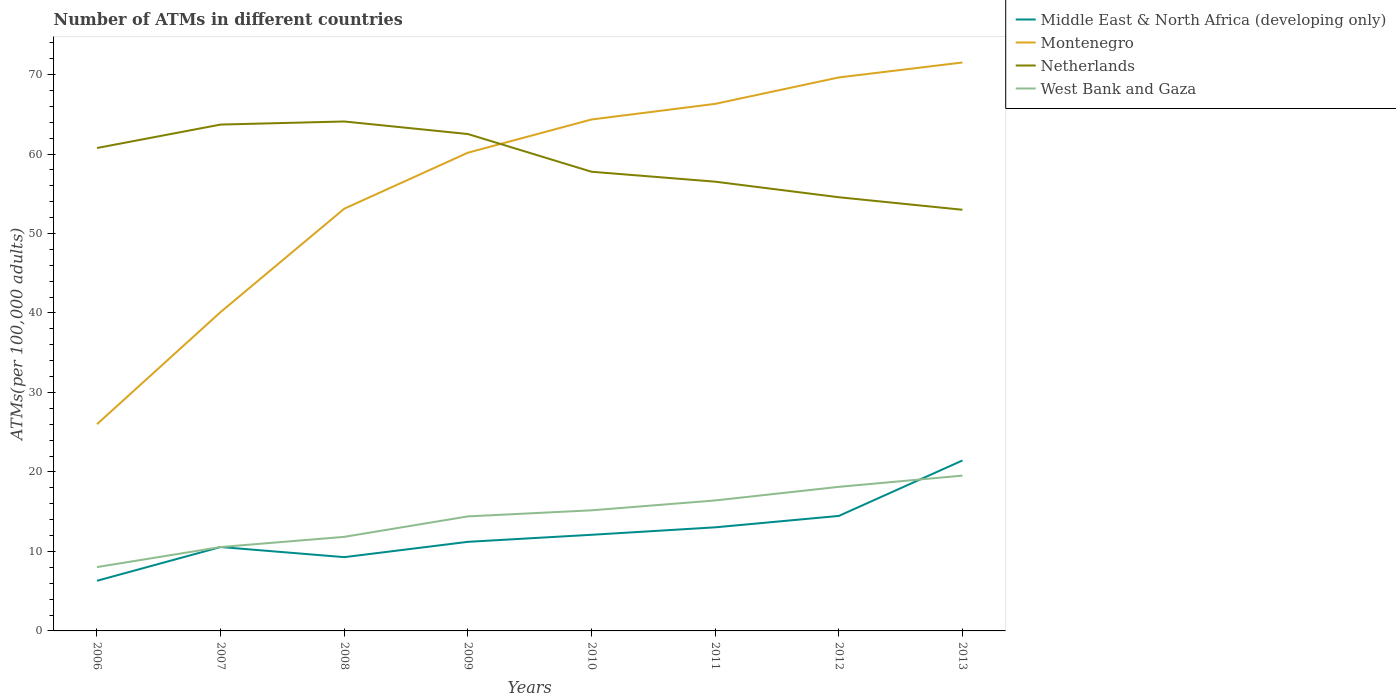How many different coloured lines are there?
Offer a terse response. 4. Does the line corresponding to Netherlands intersect with the line corresponding to Montenegro?
Your answer should be very brief. Yes. Is the number of lines equal to the number of legend labels?
Your answer should be compact. Yes. Across all years, what is the maximum number of ATMs in Middle East & North Africa (developing only)?
Provide a succinct answer. 6.31. In which year was the number of ATMs in West Bank and Gaza maximum?
Give a very brief answer. 2006. What is the total number of ATMs in Montenegro in the graph?
Ensure brevity in your answer.  -11.35. What is the difference between the highest and the second highest number of ATMs in Middle East & North Africa (developing only)?
Offer a very short reply. 15.13. How many lines are there?
Provide a short and direct response. 4. Are the values on the major ticks of Y-axis written in scientific E-notation?
Keep it short and to the point. No. Where does the legend appear in the graph?
Make the answer very short. Top right. How are the legend labels stacked?
Make the answer very short. Vertical. What is the title of the graph?
Ensure brevity in your answer.  Number of ATMs in different countries. What is the label or title of the X-axis?
Your answer should be compact. Years. What is the label or title of the Y-axis?
Your answer should be compact. ATMs(per 100,0 adults). What is the ATMs(per 100,000 adults) of Middle East & North Africa (developing only) in 2006?
Keep it short and to the point. 6.31. What is the ATMs(per 100,000 adults) of Montenegro in 2006?
Offer a very short reply. 26.01. What is the ATMs(per 100,000 adults) of Netherlands in 2006?
Give a very brief answer. 60.76. What is the ATMs(per 100,000 adults) in West Bank and Gaza in 2006?
Your answer should be compact. 8.03. What is the ATMs(per 100,000 adults) of Middle East & North Africa (developing only) in 2007?
Your answer should be compact. 10.56. What is the ATMs(per 100,000 adults) of Montenegro in 2007?
Provide a succinct answer. 40.12. What is the ATMs(per 100,000 adults) in Netherlands in 2007?
Make the answer very short. 63.71. What is the ATMs(per 100,000 adults) in West Bank and Gaza in 2007?
Keep it short and to the point. 10.56. What is the ATMs(per 100,000 adults) in Middle East & North Africa (developing only) in 2008?
Provide a short and direct response. 9.28. What is the ATMs(per 100,000 adults) of Montenegro in 2008?
Offer a very short reply. 53.12. What is the ATMs(per 100,000 adults) of Netherlands in 2008?
Keep it short and to the point. 64.1. What is the ATMs(per 100,000 adults) in West Bank and Gaza in 2008?
Keep it short and to the point. 11.84. What is the ATMs(per 100,000 adults) in Middle East & North Africa (developing only) in 2009?
Offer a very short reply. 11.21. What is the ATMs(per 100,000 adults) of Montenegro in 2009?
Provide a short and direct response. 60.17. What is the ATMs(per 100,000 adults) of Netherlands in 2009?
Your answer should be very brief. 62.52. What is the ATMs(per 100,000 adults) of West Bank and Gaza in 2009?
Provide a short and direct response. 14.41. What is the ATMs(per 100,000 adults) of Middle East & North Africa (developing only) in 2010?
Give a very brief answer. 12.09. What is the ATMs(per 100,000 adults) in Montenegro in 2010?
Give a very brief answer. 64.35. What is the ATMs(per 100,000 adults) in Netherlands in 2010?
Ensure brevity in your answer.  57.77. What is the ATMs(per 100,000 adults) of West Bank and Gaza in 2010?
Offer a terse response. 15.17. What is the ATMs(per 100,000 adults) of Middle East & North Africa (developing only) in 2011?
Provide a succinct answer. 13.03. What is the ATMs(per 100,000 adults) of Montenegro in 2011?
Your response must be concise. 66.31. What is the ATMs(per 100,000 adults) in Netherlands in 2011?
Provide a succinct answer. 56.52. What is the ATMs(per 100,000 adults) of West Bank and Gaza in 2011?
Ensure brevity in your answer.  16.42. What is the ATMs(per 100,000 adults) in Middle East & North Africa (developing only) in 2012?
Offer a terse response. 14.47. What is the ATMs(per 100,000 adults) in Montenegro in 2012?
Your answer should be compact. 69.64. What is the ATMs(per 100,000 adults) of Netherlands in 2012?
Make the answer very short. 54.56. What is the ATMs(per 100,000 adults) in West Bank and Gaza in 2012?
Provide a short and direct response. 18.13. What is the ATMs(per 100,000 adults) in Middle East & North Africa (developing only) in 2013?
Offer a very short reply. 21.44. What is the ATMs(per 100,000 adults) in Montenegro in 2013?
Ensure brevity in your answer.  71.52. What is the ATMs(per 100,000 adults) in Netherlands in 2013?
Keep it short and to the point. 52.99. What is the ATMs(per 100,000 adults) in West Bank and Gaza in 2013?
Your answer should be very brief. 19.54. Across all years, what is the maximum ATMs(per 100,000 adults) of Middle East & North Africa (developing only)?
Offer a terse response. 21.44. Across all years, what is the maximum ATMs(per 100,000 adults) of Montenegro?
Provide a succinct answer. 71.52. Across all years, what is the maximum ATMs(per 100,000 adults) in Netherlands?
Offer a terse response. 64.1. Across all years, what is the maximum ATMs(per 100,000 adults) in West Bank and Gaza?
Your answer should be compact. 19.54. Across all years, what is the minimum ATMs(per 100,000 adults) in Middle East & North Africa (developing only)?
Provide a succinct answer. 6.31. Across all years, what is the minimum ATMs(per 100,000 adults) of Montenegro?
Offer a very short reply. 26.01. Across all years, what is the minimum ATMs(per 100,000 adults) of Netherlands?
Offer a very short reply. 52.99. Across all years, what is the minimum ATMs(per 100,000 adults) of West Bank and Gaza?
Provide a short and direct response. 8.03. What is the total ATMs(per 100,000 adults) of Middle East & North Africa (developing only) in the graph?
Provide a succinct answer. 98.4. What is the total ATMs(per 100,000 adults) of Montenegro in the graph?
Give a very brief answer. 451.24. What is the total ATMs(per 100,000 adults) in Netherlands in the graph?
Your response must be concise. 472.93. What is the total ATMs(per 100,000 adults) of West Bank and Gaza in the graph?
Ensure brevity in your answer.  114.09. What is the difference between the ATMs(per 100,000 adults) in Middle East & North Africa (developing only) in 2006 and that in 2007?
Give a very brief answer. -4.25. What is the difference between the ATMs(per 100,000 adults) in Montenegro in 2006 and that in 2007?
Keep it short and to the point. -14.11. What is the difference between the ATMs(per 100,000 adults) of Netherlands in 2006 and that in 2007?
Offer a terse response. -2.95. What is the difference between the ATMs(per 100,000 adults) in West Bank and Gaza in 2006 and that in 2007?
Provide a succinct answer. -2.52. What is the difference between the ATMs(per 100,000 adults) of Middle East & North Africa (developing only) in 2006 and that in 2008?
Offer a terse response. -2.97. What is the difference between the ATMs(per 100,000 adults) in Montenegro in 2006 and that in 2008?
Ensure brevity in your answer.  -27.11. What is the difference between the ATMs(per 100,000 adults) of Netherlands in 2006 and that in 2008?
Give a very brief answer. -3.34. What is the difference between the ATMs(per 100,000 adults) in West Bank and Gaza in 2006 and that in 2008?
Offer a very short reply. -3.8. What is the difference between the ATMs(per 100,000 adults) of Middle East & North Africa (developing only) in 2006 and that in 2009?
Give a very brief answer. -4.9. What is the difference between the ATMs(per 100,000 adults) of Montenegro in 2006 and that in 2009?
Your answer should be very brief. -34.16. What is the difference between the ATMs(per 100,000 adults) in Netherlands in 2006 and that in 2009?
Your response must be concise. -1.76. What is the difference between the ATMs(per 100,000 adults) of West Bank and Gaza in 2006 and that in 2009?
Your response must be concise. -6.38. What is the difference between the ATMs(per 100,000 adults) of Middle East & North Africa (developing only) in 2006 and that in 2010?
Provide a succinct answer. -5.79. What is the difference between the ATMs(per 100,000 adults) of Montenegro in 2006 and that in 2010?
Provide a succinct answer. -38.34. What is the difference between the ATMs(per 100,000 adults) in Netherlands in 2006 and that in 2010?
Give a very brief answer. 2.99. What is the difference between the ATMs(per 100,000 adults) in West Bank and Gaza in 2006 and that in 2010?
Offer a very short reply. -7.14. What is the difference between the ATMs(per 100,000 adults) in Middle East & North Africa (developing only) in 2006 and that in 2011?
Your answer should be very brief. -6.72. What is the difference between the ATMs(per 100,000 adults) of Montenegro in 2006 and that in 2011?
Your answer should be very brief. -40.3. What is the difference between the ATMs(per 100,000 adults) of Netherlands in 2006 and that in 2011?
Provide a succinct answer. 4.24. What is the difference between the ATMs(per 100,000 adults) of West Bank and Gaza in 2006 and that in 2011?
Make the answer very short. -8.38. What is the difference between the ATMs(per 100,000 adults) of Middle East & North Africa (developing only) in 2006 and that in 2012?
Make the answer very short. -8.16. What is the difference between the ATMs(per 100,000 adults) of Montenegro in 2006 and that in 2012?
Offer a very short reply. -43.63. What is the difference between the ATMs(per 100,000 adults) of Netherlands in 2006 and that in 2012?
Your answer should be very brief. 6.19. What is the difference between the ATMs(per 100,000 adults) of West Bank and Gaza in 2006 and that in 2012?
Offer a terse response. -10.1. What is the difference between the ATMs(per 100,000 adults) of Middle East & North Africa (developing only) in 2006 and that in 2013?
Your response must be concise. -15.13. What is the difference between the ATMs(per 100,000 adults) of Montenegro in 2006 and that in 2013?
Keep it short and to the point. -45.51. What is the difference between the ATMs(per 100,000 adults) in Netherlands in 2006 and that in 2013?
Ensure brevity in your answer.  7.77. What is the difference between the ATMs(per 100,000 adults) in West Bank and Gaza in 2006 and that in 2013?
Provide a succinct answer. -11.51. What is the difference between the ATMs(per 100,000 adults) of Middle East & North Africa (developing only) in 2007 and that in 2008?
Give a very brief answer. 1.27. What is the difference between the ATMs(per 100,000 adults) of Montenegro in 2007 and that in 2008?
Give a very brief answer. -13. What is the difference between the ATMs(per 100,000 adults) in Netherlands in 2007 and that in 2008?
Ensure brevity in your answer.  -0.39. What is the difference between the ATMs(per 100,000 adults) of West Bank and Gaza in 2007 and that in 2008?
Provide a succinct answer. -1.28. What is the difference between the ATMs(per 100,000 adults) of Middle East & North Africa (developing only) in 2007 and that in 2009?
Make the answer very short. -0.65. What is the difference between the ATMs(per 100,000 adults) in Montenegro in 2007 and that in 2009?
Offer a very short reply. -20.05. What is the difference between the ATMs(per 100,000 adults) of Netherlands in 2007 and that in 2009?
Offer a very short reply. 1.19. What is the difference between the ATMs(per 100,000 adults) of West Bank and Gaza in 2007 and that in 2009?
Offer a very short reply. -3.85. What is the difference between the ATMs(per 100,000 adults) of Middle East & North Africa (developing only) in 2007 and that in 2010?
Offer a terse response. -1.54. What is the difference between the ATMs(per 100,000 adults) of Montenegro in 2007 and that in 2010?
Keep it short and to the point. -24.23. What is the difference between the ATMs(per 100,000 adults) of Netherlands in 2007 and that in 2010?
Your answer should be very brief. 5.94. What is the difference between the ATMs(per 100,000 adults) of West Bank and Gaza in 2007 and that in 2010?
Make the answer very short. -4.62. What is the difference between the ATMs(per 100,000 adults) in Middle East & North Africa (developing only) in 2007 and that in 2011?
Offer a very short reply. -2.48. What is the difference between the ATMs(per 100,000 adults) of Montenegro in 2007 and that in 2011?
Provide a short and direct response. -26.19. What is the difference between the ATMs(per 100,000 adults) of Netherlands in 2007 and that in 2011?
Offer a very short reply. 7.19. What is the difference between the ATMs(per 100,000 adults) in West Bank and Gaza in 2007 and that in 2011?
Provide a succinct answer. -5.86. What is the difference between the ATMs(per 100,000 adults) of Middle East & North Africa (developing only) in 2007 and that in 2012?
Offer a very short reply. -3.91. What is the difference between the ATMs(per 100,000 adults) of Montenegro in 2007 and that in 2012?
Your answer should be compact. -29.52. What is the difference between the ATMs(per 100,000 adults) in Netherlands in 2007 and that in 2012?
Your answer should be compact. 9.14. What is the difference between the ATMs(per 100,000 adults) of West Bank and Gaza in 2007 and that in 2012?
Make the answer very short. -7.57. What is the difference between the ATMs(per 100,000 adults) of Middle East & North Africa (developing only) in 2007 and that in 2013?
Give a very brief answer. -10.89. What is the difference between the ATMs(per 100,000 adults) of Montenegro in 2007 and that in 2013?
Ensure brevity in your answer.  -31.4. What is the difference between the ATMs(per 100,000 adults) of Netherlands in 2007 and that in 2013?
Ensure brevity in your answer.  10.72. What is the difference between the ATMs(per 100,000 adults) of West Bank and Gaza in 2007 and that in 2013?
Provide a short and direct response. -8.98. What is the difference between the ATMs(per 100,000 adults) of Middle East & North Africa (developing only) in 2008 and that in 2009?
Your answer should be very brief. -1.93. What is the difference between the ATMs(per 100,000 adults) in Montenegro in 2008 and that in 2009?
Your response must be concise. -7.05. What is the difference between the ATMs(per 100,000 adults) in Netherlands in 2008 and that in 2009?
Your answer should be very brief. 1.58. What is the difference between the ATMs(per 100,000 adults) in West Bank and Gaza in 2008 and that in 2009?
Give a very brief answer. -2.57. What is the difference between the ATMs(per 100,000 adults) in Middle East & North Africa (developing only) in 2008 and that in 2010?
Offer a very short reply. -2.81. What is the difference between the ATMs(per 100,000 adults) in Montenegro in 2008 and that in 2010?
Your answer should be compact. -11.22. What is the difference between the ATMs(per 100,000 adults) in Netherlands in 2008 and that in 2010?
Your answer should be compact. 6.32. What is the difference between the ATMs(per 100,000 adults) in West Bank and Gaza in 2008 and that in 2010?
Your answer should be compact. -3.34. What is the difference between the ATMs(per 100,000 adults) in Middle East & North Africa (developing only) in 2008 and that in 2011?
Offer a terse response. -3.75. What is the difference between the ATMs(per 100,000 adults) in Montenegro in 2008 and that in 2011?
Give a very brief answer. -13.19. What is the difference between the ATMs(per 100,000 adults) of Netherlands in 2008 and that in 2011?
Keep it short and to the point. 7.57. What is the difference between the ATMs(per 100,000 adults) of West Bank and Gaza in 2008 and that in 2011?
Give a very brief answer. -4.58. What is the difference between the ATMs(per 100,000 adults) in Middle East & North Africa (developing only) in 2008 and that in 2012?
Make the answer very short. -5.19. What is the difference between the ATMs(per 100,000 adults) in Montenegro in 2008 and that in 2012?
Provide a short and direct response. -16.51. What is the difference between the ATMs(per 100,000 adults) of Netherlands in 2008 and that in 2012?
Ensure brevity in your answer.  9.53. What is the difference between the ATMs(per 100,000 adults) in West Bank and Gaza in 2008 and that in 2012?
Ensure brevity in your answer.  -6.29. What is the difference between the ATMs(per 100,000 adults) of Middle East & North Africa (developing only) in 2008 and that in 2013?
Your answer should be compact. -12.16. What is the difference between the ATMs(per 100,000 adults) of Montenegro in 2008 and that in 2013?
Make the answer very short. -18.39. What is the difference between the ATMs(per 100,000 adults) of Netherlands in 2008 and that in 2013?
Your response must be concise. 11.11. What is the difference between the ATMs(per 100,000 adults) in West Bank and Gaza in 2008 and that in 2013?
Offer a very short reply. -7.7. What is the difference between the ATMs(per 100,000 adults) of Middle East & North Africa (developing only) in 2009 and that in 2010?
Provide a short and direct response. -0.89. What is the difference between the ATMs(per 100,000 adults) in Montenegro in 2009 and that in 2010?
Offer a very short reply. -4.18. What is the difference between the ATMs(per 100,000 adults) in Netherlands in 2009 and that in 2010?
Offer a terse response. 4.74. What is the difference between the ATMs(per 100,000 adults) in West Bank and Gaza in 2009 and that in 2010?
Keep it short and to the point. -0.76. What is the difference between the ATMs(per 100,000 adults) of Middle East & North Africa (developing only) in 2009 and that in 2011?
Make the answer very short. -1.82. What is the difference between the ATMs(per 100,000 adults) in Montenegro in 2009 and that in 2011?
Your answer should be very brief. -6.14. What is the difference between the ATMs(per 100,000 adults) in Netherlands in 2009 and that in 2011?
Offer a very short reply. 5.99. What is the difference between the ATMs(per 100,000 adults) of West Bank and Gaza in 2009 and that in 2011?
Provide a short and direct response. -2.01. What is the difference between the ATMs(per 100,000 adults) of Middle East & North Africa (developing only) in 2009 and that in 2012?
Your response must be concise. -3.26. What is the difference between the ATMs(per 100,000 adults) in Montenegro in 2009 and that in 2012?
Your answer should be very brief. -9.47. What is the difference between the ATMs(per 100,000 adults) of Netherlands in 2009 and that in 2012?
Your answer should be very brief. 7.95. What is the difference between the ATMs(per 100,000 adults) in West Bank and Gaza in 2009 and that in 2012?
Provide a short and direct response. -3.72. What is the difference between the ATMs(per 100,000 adults) in Middle East & North Africa (developing only) in 2009 and that in 2013?
Keep it short and to the point. -10.24. What is the difference between the ATMs(per 100,000 adults) of Montenegro in 2009 and that in 2013?
Offer a very short reply. -11.35. What is the difference between the ATMs(per 100,000 adults) of Netherlands in 2009 and that in 2013?
Your answer should be compact. 9.53. What is the difference between the ATMs(per 100,000 adults) in West Bank and Gaza in 2009 and that in 2013?
Your response must be concise. -5.13. What is the difference between the ATMs(per 100,000 adults) of Middle East & North Africa (developing only) in 2010 and that in 2011?
Your answer should be very brief. -0.94. What is the difference between the ATMs(per 100,000 adults) of Montenegro in 2010 and that in 2011?
Give a very brief answer. -1.96. What is the difference between the ATMs(per 100,000 adults) in Netherlands in 2010 and that in 2011?
Your answer should be very brief. 1.25. What is the difference between the ATMs(per 100,000 adults) of West Bank and Gaza in 2010 and that in 2011?
Keep it short and to the point. -1.24. What is the difference between the ATMs(per 100,000 adults) in Middle East & North Africa (developing only) in 2010 and that in 2012?
Provide a succinct answer. -2.37. What is the difference between the ATMs(per 100,000 adults) in Montenegro in 2010 and that in 2012?
Offer a terse response. -5.29. What is the difference between the ATMs(per 100,000 adults) in Netherlands in 2010 and that in 2012?
Provide a short and direct response. 3.21. What is the difference between the ATMs(per 100,000 adults) in West Bank and Gaza in 2010 and that in 2012?
Your answer should be very brief. -2.95. What is the difference between the ATMs(per 100,000 adults) in Middle East & North Africa (developing only) in 2010 and that in 2013?
Keep it short and to the point. -9.35. What is the difference between the ATMs(per 100,000 adults) of Montenegro in 2010 and that in 2013?
Make the answer very short. -7.17. What is the difference between the ATMs(per 100,000 adults) in Netherlands in 2010 and that in 2013?
Provide a succinct answer. 4.78. What is the difference between the ATMs(per 100,000 adults) of West Bank and Gaza in 2010 and that in 2013?
Give a very brief answer. -4.37. What is the difference between the ATMs(per 100,000 adults) of Middle East & North Africa (developing only) in 2011 and that in 2012?
Provide a short and direct response. -1.43. What is the difference between the ATMs(per 100,000 adults) of Montenegro in 2011 and that in 2012?
Make the answer very short. -3.32. What is the difference between the ATMs(per 100,000 adults) in Netherlands in 2011 and that in 2012?
Your response must be concise. 1.96. What is the difference between the ATMs(per 100,000 adults) of West Bank and Gaza in 2011 and that in 2012?
Make the answer very short. -1.71. What is the difference between the ATMs(per 100,000 adults) of Middle East & North Africa (developing only) in 2011 and that in 2013?
Give a very brief answer. -8.41. What is the difference between the ATMs(per 100,000 adults) of Montenegro in 2011 and that in 2013?
Provide a short and direct response. -5.21. What is the difference between the ATMs(per 100,000 adults) in Netherlands in 2011 and that in 2013?
Your answer should be compact. 3.53. What is the difference between the ATMs(per 100,000 adults) in West Bank and Gaza in 2011 and that in 2013?
Give a very brief answer. -3.12. What is the difference between the ATMs(per 100,000 adults) in Middle East & North Africa (developing only) in 2012 and that in 2013?
Your answer should be compact. -6.98. What is the difference between the ATMs(per 100,000 adults) of Montenegro in 2012 and that in 2013?
Provide a short and direct response. -1.88. What is the difference between the ATMs(per 100,000 adults) in Netherlands in 2012 and that in 2013?
Provide a short and direct response. 1.58. What is the difference between the ATMs(per 100,000 adults) of West Bank and Gaza in 2012 and that in 2013?
Offer a terse response. -1.41. What is the difference between the ATMs(per 100,000 adults) of Middle East & North Africa (developing only) in 2006 and the ATMs(per 100,000 adults) of Montenegro in 2007?
Ensure brevity in your answer.  -33.81. What is the difference between the ATMs(per 100,000 adults) in Middle East & North Africa (developing only) in 2006 and the ATMs(per 100,000 adults) in Netherlands in 2007?
Give a very brief answer. -57.4. What is the difference between the ATMs(per 100,000 adults) in Middle East & North Africa (developing only) in 2006 and the ATMs(per 100,000 adults) in West Bank and Gaza in 2007?
Offer a very short reply. -4.25. What is the difference between the ATMs(per 100,000 adults) in Montenegro in 2006 and the ATMs(per 100,000 adults) in Netherlands in 2007?
Offer a very short reply. -37.7. What is the difference between the ATMs(per 100,000 adults) of Montenegro in 2006 and the ATMs(per 100,000 adults) of West Bank and Gaza in 2007?
Provide a short and direct response. 15.46. What is the difference between the ATMs(per 100,000 adults) in Netherlands in 2006 and the ATMs(per 100,000 adults) in West Bank and Gaza in 2007?
Your answer should be very brief. 50.2. What is the difference between the ATMs(per 100,000 adults) of Middle East & North Africa (developing only) in 2006 and the ATMs(per 100,000 adults) of Montenegro in 2008?
Your response must be concise. -46.81. What is the difference between the ATMs(per 100,000 adults) of Middle East & North Africa (developing only) in 2006 and the ATMs(per 100,000 adults) of Netherlands in 2008?
Provide a short and direct response. -57.79. What is the difference between the ATMs(per 100,000 adults) of Middle East & North Africa (developing only) in 2006 and the ATMs(per 100,000 adults) of West Bank and Gaza in 2008?
Give a very brief answer. -5.53. What is the difference between the ATMs(per 100,000 adults) in Montenegro in 2006 and the ATMs(per 100,000 adults) in Netherlands in 2008?
Provide a succinct answer. -38.09. What is the difference between the ATMs(per 100,000 adults) of Montenegro in 2006 and the ATMs(per 100,000 adults) of West Bank and Gaza in 2008?
Ensure brevity in your answer.  14.18. What is the difference between the ATMs(per 100,000 adults) in Netherlands in 2006 and the ATMs(per 100,000 adults) in West Bank and Gaza in 2008?
Provide a short and direct response. 48.92. What is the difference between the ATMs(per 100,000 adults) of Middle East & North Africa (developing only) in 2006 and the ATMs(per 100,000 adults) of Montenegro in 2009?
Give a very brief answer. -53.86. What is the difference between the ATMs(per 100,000 adults) in Middle East & North Africa (developing only) in 2006 and the ATMs(per 100,000 adults) in Netherlands in 2009?
Offer a very short reply. -56.21. What is the difference between the ATMs(per 100,000 adults) in Montenegro in 2006 and the ATMs(per 100,000 adults) in Netherlands in 2009?
Provide a succinct answer. -36.51. What is the difference between the ATMs(per 100,000 adults) in Montenegro in 2006 and the ATMs(per 100,000 adults) in West Bank and Gaza in 2009?
Make the answer very short. 11.6. What is the difference between the ATMs(per 100,000 adults) in Netherlands in 2006 and the ATMs(per 100,000 adults) in West Bank and Gaza in 2009?
Offer a terse response. 46.35. What is the difference between the ATMs(per 100,000 adults) of Middle East & North Africa (developing only) in 2006 and the ATMs(per 100,000 adults) of Montenegro in 2010?
Give a very brief answer. -58.04. What is the difference between the ATMs(per 100,000 adults) in Middle East & North Africa (developing only) in 2006 and the ATMs(per 100,000 adults) in Netherlands in 2010?
Keep it short and to the point. -51.46. What is the difference between the ATMs(per 100,000 adults) in Middle East & North Africa (developing only) in 2006 and the ATMs(per 100,000 adults) in West Bank and Gaza in 2010?
Your response must be concise. -8.86. What is the difference between the ATMs(per 100,000 adults) of Montenegro in 2006 and the ATMs(per 100,000 adults) of Netherlands in 2010?
Offer a terse response. -31.76. What is the difference between the ATMs(per 100,000 adults) of Montenegro in 2006 and the ATMs(per 100,000 adults) of West Bank and Gaza in 2010?
Your answer should be compact. 10.84. What is the difference between the ATMs(per 100,000 adults) of Netherlands in 2006 and the ATMs(per 100,000 adults) of West Bank and Gaza in 2010?
Ensure brevity in your answer.  45.58. What is the difference between the ATMs(per 100,000 adults) of Middle East & North Africa (developing only) in 2006 and the ATMs(per 100,000 adults) of Montenegro in 2011?
Your answer should be compact. -60. What is the difference between the ATMs(per 100,000 adults) of Middle East & North Africa (developing only) in 2006 and the ATMs(per 100,000 adults) of Netherlands in 2011?
Make the answer very short. -50.21. What is the difference between the ATMs(per 100,000 adults) in Middle East & North Africa (developing only) in 2006 and the ATMs(per 100,000 adults) in West Bank and Gaza in 2011?
Your answer should be compact. -10.11. What is the difference between the ATMs(per 100,000 adults) of Montenegro in 2006 and the ATMs(per 100,000 adults) of Netherlands in 2011?
Make the answer very short. -30.51. What is the difference between the ATMs(per 100,000 adults) of Montenegro in 2006 and the ATMs(per 100,000 adults) of West Bank and Gaza in 2011?
Your answer should be compact. 9.6. What is the difference between the ATMs(per 100,000 adults) of Netherlands in 2006 and the ATMs(per 100,000 adults) of West Bank and Gaza in 2011?
Keep it short and to the point. 44.34. What is the difference between the ATMs(per 100,000 adults) in Middle East & North Africa (developing only) in 2006 and the ATMs(per 100,000 adults) in Montenegro in 2012?
Provide a succinct answer. -63.33. What is the difference between the ATMs(per 100,000 adults) of Middle East & North Africa (developing only) in 2006 and the ATMs(per 100,000 adults) of Netherlands in 2012?
Your response must be concise. -48.25. What is the difference between the ATMs(per 100,000 adults) of Middle East & North Africa (developing only) in 2006 and the ATMs(per 100,000 adults) of West Bank and Gaza in 2012?
Your answer should be very brief. -11.82. What is the difference between the ATMs(per 100,000 adults) in Montenegro in 2006 and the ATMs(per 100,000 adults) in Netherlands in 2012?
Your response must be concise. -28.55. What is the difference between the ATMs(per 100,000 adults) in Montenegro in 2006 and the ATMs(per 100,000 adults) in West Bank and Gaza in 2012?
Offer a terse response. 7.88. What is the difference between the ATMs(per 100,000 adults) of Netherlands in 2006 and the ATMs(per 100,000 adults) of West Bank and Gaza in 2012?
Give a very brief answer. 42.63. What is the difference between the ATMs(per 100,000 adults) in Middle East & North Africa (developing only) in 2006 and the ATMs(per 100,000 adults) in Montenegro in 2013?
Make the answer very short. -65.21. What is the difference between the ATMs(per 100,000 adults) in Middle East & North Africa (developing only) in 2006 and the ATMs(per 100,000 adults) in Netherlands in 2013?
Provide a succinct answer. -46.68. What is the difference between the ATMs(per 100,000 adults) in Middle East & North Africa (developing only) in 2006 and the ATMs(per 100,000 adults) in West Bank and Gaza in 2013?
Provide a succinct answer. -13.23. What is the difference between the ATMs(per 100,000 adults) in Montenegro in 2006 and the ATMs(per 100,000 adults) in Netherlands in 2013?
Offer a very short reply. -26.98. What is the difference between the ATMs(per 100,000 adults) of Montenegro in 2006 and the ATMs(per 100,000 adults) of West Bank and Gaza in 2013?
Your response must be concise. 6.47. What is the difference between the ATMs(per 100,000 adults) of Netherlands in 2006 and the ATMs(per 100,000 adults) of West Bank and Gaza in 2013?
Offer a very short reply. 41.22. What is the difference between the ATMs(per 100,000 adults) of Middle East & North Africa (developing only) in 2007 and the ATMs(per 100,000 adults) of Montenegro in 2008?
Ensure brevity in your answer.  -42.57. What is the difference between the ATMs(per 100,000 adults) of Middle East & North Africa (developing only) in 2007 and the ATMs(per 100,000 adults) of Netherlands in 2008?
Your answer should be very brief. -53.54. What is the difference between the ATMs(per 100,000 adults) in Middle East & North Africa (developing only) in 2007 and the ATMs(per 100,000 adults) in West Bank and Gaza in 2008?
Your answer should be compact. -1.28. What is the difference between the ATMs(per 100,000 adults) of Montenegro in 2007 and the ATMs(per 100,000 adults) of Netherlands in 2008?
Give a very brief answer. -23.98. What is the difference between the ATMs(per 100,000 adults) in Montenegro in 2007 and the ATMs(per 100,000 adults) in West Bank and Gaza in 2008?
Provide a short and direct response. 28.28. What is the difference between the ATMs(per 100,000 adults) in Netherlands in 2007 and the ATMs(per 100,000 adults) in West Bank and Gaza in 2008?
Provide a succinct answer. 51.87. What is the difference between the ATMs(per 100,000 adults) of Middle East & North Africa (developing only) in 2007 and the ATMs(per 100,000 adults) of Montenegro in 2009?
Provide a succinct answer. -49.61. What is the difference between the ATMs(per 100,000 adults) in Middle East & North Africa (developing only) in 2007 and the ATMs(per 100,000 adults) in Netherlands in 2009?
Offer a terse response. -51.96. What is the difference between the ATMs(per 100,000 adults) in Middle East & North Africa (developing only) in 2007 and the ATMs(per 100,000 adults) in West Bank and Gaza in 2009?
Give a very brief answer. -3.85. What is the difference between the ATMs(per 100,000 adults) in Montenegro in 2007 and the ATMs(per 100,000 adults) in Netherlands in 2009?
Give a very brief answer. -22.4. What is the difference between the ATMs(per 100,000 adults) in Montenegro in 2007 and the ATMs(per 100,000 adults) in West Bank and Gaza in 2009?
Keep it short and to the point. 25.71. What is the difference between the ATMs(per 100,000 adults) of Netherlands in 2007 and the ATMs(per 100,000 adults) of West Bank and Gaza in 2009?
Ensure brevity in your answer.  49.3. What is the difference between the ATMs(per 100,000 adults) of Middle East & North Africa (developing only) in 2007 and the ATMs(per 100,000 adults) of Montenegro in 2010?
Your answer should be compact. -53.79. What is the difference between the ATMs(per 100,000 adults) of Middle East & North Africa (developing only) in 2007 and the ATMs(per 100,000 adults) of Netherlands in 2010?
Your answer should be compact. -47.22. What is the difference between the ATMs(per 100,000 adults) in Middle East & North Africa (developing only) in 2007 and the ATMs(per 100,000 adults) in West Bank and Gaza in 2010?
Offer a very short reply. -4.62. What is the difference between the ATMs(per 100,000 adults) in Montenegro in 2007 and the ATMs(per 100,000 adults) in Netherlands in 2010?
Make the answer very short. -17.65. What is the difference between the ATMs(per 100,000 adults) of Montenegro in 2007 and the ATMs(per 100,000 adults) of West Bank and Gaza in 2010?
Your answer should be compact. 24.95. What is the difference between the ATMs(per 100,000 adults) of Netherlands in 2007 and the ATMs(per 100,000 adults) of West Bank and Gaza in 2010?
Ensure brevity in your answer.  48.53. What is the difference between the ATMs(per 100,000 adults) of Middle East & North Africa (developing only) in 2007 and the ATMs(per 100,000 adults) of Montenegro in 2011?
Provide a succinct answer. -55.76. What is the difference between the ATMs(per 100,000 adults) in Middle East & North Africa (developing only) in 2007 and the ATMs(per 100,000 adults) in Netherlands in 2011?
Make the answer very short. -45.97. What is the difference between the ATMs(per 100,000 adults) in Middle East & North Africa (developing only) in 2007 and the ATMs(per 100,000 adults) in West Bank and Gaza in 2011?
Offer a very short reply. -5.86. What is the difference between the ATMs(per 100,000 adults) of Montenegro in 2007 and the ATMs(per 100,000 adults) of Netherlands in 2011?
Make the answer very short. -16.4. What is the difference between the ATMs(per 100,000 adults) in Montenegro in 2007 and the ATMs(per 100,000 adults) in West Bank and Gaza in 2011?
Make the answer very short. 23.7. What is the difference between the ATMs(per 100,000 adults) in Netherlands in 2007 and the ATMs(per 100,000 adults) in West Bank and Gaza in 2011?
Keep it short and to the point. 47.29. What is the difference between the ATMs(per 100,000 adults) in Middle East & North Africa (developing only) in 2007 and the ATMs(per 100,000 adults) in Montenegro in 2012?
Keep it short and to the point. -59.08. What is the difference between the ATMs(per 100,000 adults) in Middle East & North Africa (developing only) in 2007 and the ATMs(per 100,000 adults) in Netherlands in 2012?
Offer a terse response. -44.01. What is the difference between the ATMs(per 100,000 adults) of Middle East & North Africa (developing only) in 2007 and the ATMs(per 100,000 adults) of West Bank and Gaza in 2012?
Give a very brief answer. -7.57. What is the difference between the ATMs(per 100,000 adults) in Montenegro in 2007 and the ATMs(per 100,000 adults) in Netherlands in 2012?
Keep it short and to the point. -14.44. What is the difference between the ATMs(per 100,000 adults) in Montenegro in 2007 and the ATMs(per 100,000 adults) in West Bank and Gaza in 2012?
Offer a terse response. 21.99. What is the difference between the ATMs(per 100,000 adults) of Netherlands in 2007 and the ATMs(per 100,000 adults) of West Bank and Gaza in 2012?
Provide a short and direct response. 45.58. What is the difference between the ATMs(per 100,000 adults) of Middle East & North Africa (developing only) in 2007 and the ATMs(per 100,000 adults) of Montenegro in 2013?
Offer a terse response. -60.96. What is the difference between the ATMs(per 100,000 adults) of Middle East & North Africa (developing only) in 2007 and the ATMs(per 100,000 adults) of Netherlands in 2013?
Your response must be concise. -42.43. What is the difference between the ATMs(per 100,000 adults) of Middle East & North Africa (developing only) in 2007 and the ATMs(per 100,000 adults) of West Bank and Gaza in 2013?
Offer a very short reply. -8.98. What is the difference between the ATMs(per 100,000 adults) of Montenegro in 2007 and the ATMs(per 100,000 adults) of Netherlands in 2013?
Provide a succinct answer. -12.87. What is the difference between the ATMs(per 100,000 adults) in Montenegro in 2007 and the ATMs(per 100,000 adults) in West Bank and Gaza in 2013?
Your answer should be very brief. 20.58. What is the difference between the ATMs(per 100,000 adults) in Netherlands in 2007 and the ATMs(per 100,000 adults) in West Bank and Gaza in 2013?
Make the answer very short. 44.17. What is the difference between the ATMs(per 100,000 adults) of Middle East & North Africa (developing only) in 2008 and the ATMs(per 100,000 adults) of Montenegro in 2009?
Offer a very short reply. -50.89. What is the difference between the ATMs(per 100,000 adults) in Middle East & North Africa (developing only) in 2008 and the ATMs(per 100,000 adults) in Netherlands in 2009?
Make the answer very short. -53.24. What is the difference between the ATMs(per 100,000 adults) in Middle East & North Africa (developing only) in 2008 and the ATMs(per 100,000 adults) in West Bank and Gaza in 2009?
Make the answer very short. -5.13. What is the difference between the ATMs(per 100,000 adults) in Montenegro in 2008 and the ATMs(per 100,000 adults) in Netherlands in 2009?
Keep it short and to the point. -9.39. What is the difference between the ATMs(per 100,000 adults) in Montenegro in 2008 and the ATMs(per 100,000 adults) in West Bank and Gaza in 2009?
Offer a terse response. 38.71. What is the difference between the ATMs(per 100,000 adults) of Netherlands in 2008 and the ATMs(per 100,000 adults) of West Bank and Gaza in 2009?
Give a very brief answer. 49.69. What is the difference between the ATMs(per 100,000 adults) of Middle East & North Africa (developing only) in 2008 and the ATMs(per 100,000 adults) of Montenegro in 2010?
Your answer should be very brief. -55.07. What is the difference between the ATMs(per 100,000 adults) of Middle East & North Africa (developing only) in 2008 and the ATMs(per 100,000 adults) of Netherlands in 2010?
Your answer should be compact. -48.49. What is the difference between the ATMs(per 100,000 adults) of Middle East & North Africa (developing only) in 2008 and the ATMs(per 100,000 adults) of West Bank and Gaza in 2010?
Offer a terse response. -5.89. What is the difference between the ATMs(per 100,000 adults) in Montenegro in 2008 and the ATMs(per 100,000 adults) in Netherlands in 2010?
Give a very brief answer. -4.65. What is the difference between the ATMs(per 100,000 adults) in Montenegro in 2008 and the ATMs(per 100,000 adults) in West Bank and Gaza in 2010?
Provide a succinct answer. 37.95. What is the difference between the ATMs(per 100,000 adults) of Netherlands in 2008 and the ATMs(per 100,000 adults) of West Bank and Gaza in 2010?
Offer a terse response. 48.92. What is the difference between the ATMs(per 100,000 adults) of Middle East & North Africa (developing only) in 2008 and the ATMs(per 100,000 adults) of Montenegro in 2011?
Keep it short and to the point. -57.03. What is the difference between the ATMs(per 100,000 adults) in Middle East & North Africa (developing only) in 2008 and the ATMs(per 100,000 adults) in Netherlands in 2011?
Provide a short and direct response. -47.24. What is the difference between the ATMs(per 100,000 adults) of Middle East & North Africa (developing only) in 2008 and the ATMs(per 100,000 adults) of West Bank and Gaza in 2011?
Offer a terse response. -7.13. What is the difference between the ATMs(per 100,000 adults) in Montenegro in 2008 and the ATMs(per 100,000 adults) in Netherlands in 2011?
Your answer should be compact. -3.4. What is the difference between the ATMs(per 100,000 adults) of Montenegro in 2008 and the ATMs(per 100,000 adults) of West Bank and Gaza in 2011?
Your answer should be compact. 36.71. What is the difference between the ATMs(per 100,000 adults) of Netherlands in 2008 and the ATMs(per 100,000 adults) of West Bank and Gaza in 2011?
Your answer should be compact. 47.68. What is the difference between the ATMs(per 100,000 adults) in Middle East & North Africa (developing only) in 2008 and the ATMs(per 100,000 adults) in Montenegro in 2012?
Your response must be concise. -60.35. What is the difference between the ATMs(per 100,000 adults) in Middle East & North Africa (developing only) in 2008 and the ATMs(per 100,000 adults) in Netherlands in 2012?
Keep it short and to the point. -45.28. What is the difference between the ATMs(per 100,000 adults) in Middle East & North Africa (developing only) in 2008 and the ATMs(per 100,000 adults) in West Bank and Gaza in 2012?
Offer a terse response. -8.85. What is the difference between the ATMs(per 100,000 adults) of Montenegro in 2008 and the ATMs(per 100,000 adults) of Netherlands in 2012?
Your answer should be compact. -1.44. What is the difference between the ATMs(per 100,000 adults) in Montenegro in 2008 and the ATMs(per 100,000 adults) in West Bank and Gaza in 2012?
Make the answer very short. 35. What is the difference between the ATMs(per 100,000 adults) in Netherlands in 2008 and the ATMs(per 100,000 adults) in West Bank and Gaza in 2012?
Provide a short and direct response. 45.97. What is the difference between the ATMs(per 100,000 adults) of Middle East & North Africa (developing only) in 2008 and the ATMs(per 100,000 adults) of Montenegro in 2013?
Provide a succinct answer. -62.24. What is the difference between the ATMs(per 100,000 adults) of Middle East & North Africa (developing only) in 2008 and the ATMs(per 100,000 adults) of Netherlands in 2013?
Ensure brevity in your answer.  -43.71. What is the difference between the ATMs(per 100,000 adults) of Middle East & North Africa (developing only) in 2008 and the ATMs(per 100,000 adults) of West Bank and Gaza in 2013?
Provide a succinct answer. -10.26. What is the difference between the ATMs(per 100,000 adults) in Montenegro in 2008 and the ATMs(per 100,000 adults) in Netherlands in 2013?
Give a very brief answer. 0.13. What is the difference between the ATMs(per 100,000 adults) of Montenegro in 2008 and the ATMs(per 100,000 adults) of West Bank and Gaza in 2013?
Provide a succinct answer. 33.58. What is the difference between the ATMs(per 100,000 adults) of Netherlands in 2008 and the ATMs(per 100,000 adults) of West Bank and Gaza in 2013?
Ensure brevity in your answer.  44.56. What is the difference between the ATMs(per 100,000 adults) in Middle East & North Africa (developing only) in 2009 and the ATMs(per 100,000 adults) in Montenegro in 2010?
Provide a short and direct response. -53.14. What is the difference between the ATMs(per 100,000 adults) in Middle East & North Africa (developing only) in 2009 and the ATMs(per 100,000 adults) in Netherlands in 2010?
Offer a terse response. -46.56. What is the difference between the ATMs(per 100,000 adults) in Middle East & North Africa (developing only) in 2009 and the ATMs(per 100,000 adults) in West Bank and Gaza in 2010?
Provide a succinct answer. -3.96. What is the difference between the ATMs(per 100,000 adults) in Montenegro in 2009 and the ATMs(per 100,000 adults) in Netherlands in 2010?
Keep it short and to the point. 2.4. What is the difference between the ATMs(per 100,000 adults) of Montenegro in 2009 and the ATMs(per 100,000 adults) of West Bank and Gaza in 2010?
Provide a succinct answer. 44.99. What is the difference between the ATMs(per 100,000 adults) in Netherlands in 2009 and the ATMs(per 100,000 adults) in West Bank and Gaza in 2010?
Your answer should be compact. 47.34. What is the difference between the ATMs(per 100,000 adults) of Middle East & North Africa (developing only) in 2009 and the ATMs(per 100,000 adults) of Montenegro in 2011?
Ensure brevity in your answer.  -55.1. What is the difference between the ATMs(per 100,000 adults) of Middle East & North Africa (developing only) in 2009 and the ATMs(per 100,000 adults) of Netherlands in 2011?
Make the answer very short. -45.31. What is the difference between the ATMs(per 100,000 adults) in Middle East & North Africa (developing only) in 2009 and the ATMs(per 100,000 adults) in West Bank and Gaza in 2011?
Your response must be concise. -5.21. What is the difference between the ATMs(per 100,000 adults) of Montenegro in 2009 and the ATMs(per 100,000 adults) of Netherlands in 2011?
Your answer should be very brief. 3.65. What is the difference between the ATMs(per 100,000 adults) in Montenegro in 2009 and the ATMs(per 100,000 adults) in West Bank and Gaza in 2011?
Your response must be concise. 43.75. What is the difference between the ATMs(per 100,000 adults) in Netherlands in 2009 and the ATMs(per 100,000 adults) in West Bank and Gaza in 2011?
Offer a terse response. 46.1. What is the difference between the ATMs(per 100,000 adults) in Middle East & North Africa (developing only) in 2009 and the ATMs(per 100,000 adults) in Montenegro in 2012?
Your answer should be compact. -58.43. What is the difference between the ATMs(per 100,000 adults) of Middle East & North Africa (developing only) in 2009 and the ATMs(per 100,000 adults) of Netherlands in 2012?
Provide a short and direct response. -43.36. What is the difference between the ATMs(per 100,000 adults) in Middle East & North Africa (developing only) in 2009 and the ATMs(per 100,000 adults) in West Bank and Gaza in 2012?
Give a very brief answer. -6.92. What is the difference between the ATMs(per 100,000 adults) of Montenegro in 2009 and the ATMs(per 100,000 adults) of Netherlands in 2012?
Offer a very short reply. 5.6. What is the difference between the ATMs(per 100,000 adults) in Montenegro in 2009 and the ATMs(per 100,000 adults) in West Bank and Gaza in 2012?
Your answer should be very brief. 42.04. What is the difference between the ATMs(per 100,000 adults) of Netherlands in 2009 and the ATMs(per 100,000 adults) of West Bank and Gaza in 2012?
Keep it short and to the point. 44.39. What is the difference between the ATMs(per 100,000 adults) of Middle East & North Africa (developing only) in 2009 and the ATMs(per 100,000 adults) of Montenegro in 2013?
Your answer should be compact. -60.31. What is the difference between the ATMs(per 100,000 adults) of Middle East & North Africa (developing only) in 2009 and the ATMs(per 100,000 adults) of Netherlands in 2013?
Give a very brief answer. -41.78. What is the difference between the ATMs(per 100,000 adults) of Middle East & North Africa (developing only) in 2009 and the ATMs(per 100,000 adults) of West Bank and Gaza in 2013?
Your answer should be very brief. -8.33. What is the difference between the ATMs(per 100,000 adults) in Montenegro in 2009 and the ATMs(per 100,000 adults) in Netherlands in 2013?
Make the answer very short. 7.18. What is the difference between the ATMs(per 100,000 adults) of Montenegro in 2009 and the ATMs(per 100,000 adults) of West Bank and Gaza in 2013?
Provide a short and direct response. 40.63. What is the difference between the ATMs(per 100,000 adults) in Netherlands in 2009 and the ATMs(per 100,000 adults) in West Bank and Gaza in 2013?
Ensure brevity in your answer.  42.98. What is the difference between the ATMs(per 100,000 adults) in Middle East & North Africa (developing only) in 2010 and the ATMs(per 100,000 adults) in Montenegro in 2011?
Offer a very short reply. -54.22. What is the difference between the ATMs(per 100,000 adults) in Middle East & North Africa (developing only) in 2010 and the ATMs(per 100,000 adults) in Netherlands in 2011?
Make the answer very short. -44.43. What is the difference between the ATMs(per 100,000 adults) in Middle East & North Africa (developing only) in 2010 and the ATMs(per 100,000 adults) in West Bank and Gaza in 2011?
Offer a terse response. -4.32. What is the difference between the ATMs(per 100,000 adults) of Montenegro in 2010 and the ATMs(per 100,000 adults) of Netherlands in 2011?
Offer a very short reply. 7.82. What is the difference between the ATMs(per 100,000 adults) in Montenegro in 2010 and the ATMs(per 100,000 adults) in West Bank and Gaza in 2011?
Make the answer very short. 47.93. What is the difference between the ATMs(per 100,000 adults) of Netherlands in 2010 and the ATMs(per 100,000 adults) of West Bank and Gaza in 2011?
Provide a succinct answer. 41.36. What is the difference between the ATMs(per 100,000 adults) of Middle East & North Africa (developing only) in 2010 and the ATMs(per 100,000 adults) of Montenegro in 2012?
Your answer should be very brief. -57.54. What is the difference between the ATMs(per 100,000 adults) in Middle East & North Africa (developing only) in 2010 and the ATMs(per 100,000 adults) in Netherlands in 2012?
Your answer should be very brief. -42.47. What is the difference between the ATMs(per 100,000 adults) in Middle East & North Africa (developing only) in 2010 and the ATMs(per 100,000 adults) in West Bank and Gaza in 2012?
Your response must be concise. -6.03. What is the difference between the ATMs(per 100,000 adults) in Montenegro in 2010 and the ATMs(per 100,000 adults) in Netherlands in 2012?
Ensure brevity in your answer.  9.78. What is the difference between the ATMs(per 100,000 adults) of Montenegro in 2010 and the ATMs(per 100,000 adults) of West Bank and Gaza in 2012?
Your response must be concise. 46.22. What is the difference between the ATMs(per 100,000 adults) of Netherlands in 2010 and the ATMs(per 100,000 adults) of West Bank and Gaza in 2012?
Keep it short and to the point. 39.64. What is the difference between the ATMs(per 100,000 adults) of Middle East & North Africa (developing only) in 2010 and the ATMs(per 100,000 adults) of Montenegro in 2013?
Provide a short and direct response. -59.42. What is the difference between the ATMs(per 100,000 adults) in Middle East & North Africa (developing only) in 2010 and the ATMs(per 100,000 adults) in Netherlands in 2013?
Your response must be concise. -40.89. What is the difference between the ATMs(per 100,000 adults) in Middle East & North Africa (developing only) in 2010 and the ATMs(per 100,000 adults) in West Bank and Gaza in 2013?
Your answer should be compact. -7.45. What is the difference between the ATMs(per 100,000 adults) of Montenegro in 2010 and the ATMs(per 100,000 adults) of Netherlands in 2013?
Provide a succinct answer. 11.36. What is the difference between the ATMs(per 100,000 adults) of Montenegro in 2010 and the ATMs(per 100,000 adults) of West Bank and Gaza in 2013?
Your answer should be compact. 44.81. What is the difference between the ATMs(per 100,000 adults) of Netherlands in 2010 and the ATMs(per 100,000 adults) of West Bank and Gaza in 2013?
Offer a terse response. 38.23. What is the difference between the ATMs(per 100,000 adults) in Middle East & North Africa (developing only) in 2011 and the ATMs(per 100,000 adults) in Montenegro in 2012?
Offer a terse response. -56.6. What is the difference between the ATMs(per 100,000 adults) of Middle East & North Africa (developing only) in 2011 and the ATMs(per 100,000 adults) of Netherlands in 2012?
Offer a very short reply. -41.53. What is the difference between the ATMs(per 100,000 adults) in Middle East & North Africa (developing only) in 2011 and the ATMs(per 100,000 adults) in West Bank and Gaza in 2012?
Give a very brief answer. -5.09. What is the difference between the ATMs(per 100,000 adults) of Montenegro in 2011 and the ATMs(per 100,000 adults) of Netherlands in 2012?
Make the answer very short. 11.75. What is the difference between the ATMs(per 100,000 adults) in Montenegro in 2011 and the ATMs(per 100,000 adults) in West Bank and Gaza in 2012?
Provide a succinct answer. 48.18. What is the difference between the ATMs(per 100,000 adults) of Netherlands in 2011 and the ATMs(per 100,000 adults) of West Bank and Gaza in 2012?
Offer a terse response. 38.4. What is the difference between the ATMs(per 100,000 adults) in Middle East & North Africa (developing only) in 2011 and the ATMs(per 100,000 adults) in Montenegro in 2013?
Give a very brief answer. -58.48. What is the difference between the ATMs(per 100,000 adults) in Middle East & North Africa (developing only) in 2011 and the ATMs(per 100,000 adults) in Netherlands in 2013?
Offer a very short reply. -39.95. What is the difference between the ATMs(per 100,000 adults) in Middle East & North Africa (developing only) in 2011 and the ATMs(per 100,000 adults) in West Bank and Gaza in 2013?
Provide a succinct answer. -6.51. What is the difference between the ATMs(per 100,000 adults) in Montenegro in 2011 and the ATMs(per 100,000 adults) in Netherlands in 2013?
Your answer should be very brief. 13.32. What is the difference between the ATMs(per 100,000 adults) in Montenegro in 2011 and the ATMs(per 100,000 adults) in West Bank and Gaza in 2013?
Your response must be concise. 46.77. What is the difference between the ATMs(per 100,000 adults) of Netherlands in 2011 and the ATMs(per 100,000 adults) of West Bank and Gaza in 2013?
Keep it short and to the point. 36.98. What is the difference between the ATMs(per 100,000 adults) in Middle East & North Africa (developing only) in 2012 and the ATMs(per 100,000 adults) in Montenegro in 2013?
Your response must be concise. -57.05. What is the difference between the ATMs(per 100,000 adults) of Middle East & North Africa (developing only) in 2012 and the ATMs(per 100,000 adults) of Netherlands in 2013?
Ensure brevity in your answer.  -38.52. What is the difference between the ATMs(per 100,000 adults) in Middle East & North Africa (developing only) in 2012 and the ATMs(per 100,000 adults) in West Bank and Gaza in 2013?
Offer a very short reply. -5.07. What is the difference between the ATMs(per 100,000 adults) in Montenegro in 2012 and the ATMs(per 100,000 adults) in Netherlands in 2013?
Provide a short and direct response. 16.65. What is the difference between the ATMs(per 100,000 adults) in Montenegro in 2012 and the ATMs(per 100,000 adults) in West Bank and Gaza in 2013?
Provide a succinct answer. 50.1. What is the difference between the ATMs(per 100,000 adults) of Netherlands in 2012 and the ATMs(per 100,000 adults) of West Bank and Gaza in 2013?
Provide a short and direct response. 35.02. What is the average ATMs(per 100,000 adults) in Middle East & North Africa (developing only) per year?
Offer a terse response. 12.3. What is the average ATMs(per 100,000 adults) of Montenegro per year?
Your answer should be very brief. 56.4. What is the average ATMs(per 100,000 adults) of Netherlands per year?
Your answer should be compact. 59.12. What is the average ATMs(per 100,000 adults) of West Bank and Gaza per year?
Your answer should be compact. 14.26. In the year 2006, what is the difference between the ATMs(per 100,000 adults) in Middle East & North Africa (developing only) and ATMs(per 100,000 adults) in Montenegro?
Offer a terse response. -19.7. In the year 2006, what is the difference between the ATMs(per 100,000 adults) of Middle East & North Africa (developing only) and ATMs(per 100,000 adults) of Netherlands?
Offer a terse response. -54.45. In the year 2006, what is the difference between the ATMs(per 100,000 adults) of Middle East & North Africa (developing only) and ATMs(per 100,000 adults) of West Bank and Gaza?
Provide a short and direct response. -1.72. In the year 2006, what is the difference between the ATMs(per 100,000 adults) in Montenegro and ATMs(per 100,000 adults) in Netherlands?
Offer a terse response. -34.75. In the year 2006, what is the difference between the ATMs(per 100,000 adults) of Montenegro and ATMs(per 100,000 adults) of West Bank and Gaza?
Your response must be concise. 17.98. In the year 2006, what is the difference between the ATMs(per 100,000 adults) in Netherlands and ATMs(per 100,000 adults) in West Bank and Gaza?
Make the answer very short. 52.73. In the year 2007, what is the difference between the ATMs(per 100,000 adults) in Middle East & North Africa (developing only) and ATMs(per 100,000 adults) in Montenegro?
Offer a very short reply. -29.57. In the year 2007, what is the difference between the ATMs(per 100,000 adults) of Middle East & North Africa (developing only) and ATMs(per 100,000 adults) of Netherlands?
Ensure brevity in your answer.  -53.15. In the year 2007, what is the difference between the ATMs(per 100,000 adults) of Middle East & North Africa (developing only) and ATMs(per 100,000 adults) of West Bank and Gaza?
Your response must be concise. 0. In the year 2007, what is the difference between the ATMs(per 100,000 adults) of Montenegro and ATMs(per 100,000 adults) of Netherlands?
Your answer should be very brief. -23.59. In the year 2007, what is the difference between the ATMs(per 100,000 adults) in Montenegro and ATMs(per 100,000 adults) in West Bank and Gaza?
Your response must be concise. 29.57. In the year 2007, what is the difference between the ATMs(per 100,000 adults) of Netherlands and ATMs(per 100,000 adults) of West Bank and Gaza?
Make the answer very short. 53.15. In the year 2008, what is the difference between the ATMs(per 100,000 adults) of Middle East & North Africa (developing only) and ATMs(per 100,000 adults) of Montenegro?
Your answer should be compact. -43.84. In the year 2008, what is the difference between the ATMs(per 100,000 adults) in Middle East & North Africa (developing only) and ATMs(per 100,000 adults) in Netherlands?
Ensure brevity in your answer.  -54.81. In the year 2008, what is the difference between the ATMs(per 100,000 adults) in Middle East & North Africa (developing only) and ATMs(per 100,000 adults) in West Bank and Gaza?
Provide a short and direct response. -2.55. In the year 2008, what is the difference between the ATMs(per 100,000 adults) of Montenegro and ATMs(per 100,000 adults) of Netherlands?
Your answer should be compact. -10.97. In the year 2008, what is the difference between the ATMs(per 100,000 adults) in Montenegro and ATMs(per 100,000 adults) in West Bank and Gaza?
Offer a terse response. 41.29. In the year 2008, what is the difference between the ATMs(per 100,000 adults) in Netherlands and ATMs(per 100,000 adults) in West Bank and Gaza?
Make the answer very short. 52.26. In the year 2009, what is the difference between the ATMs(per 100,000 adults) in Middle East & North Africa (developing only) and ATMs(per 100,000 adults) in Montenegro?
Your answer should be compact. -48.96. In the year 2009, what is the difference between the ATMs(per 100,000 adults) in Middle East & North Africa (developing only) and ATMs(per 100,000 adults) in Netherlands?
Your response must be concise. -51.31. In the year 2009, what is the difference between the ATMs(per 100,000 adults) of Middle East & North Africa (developing only) and ATMs(per 100,000 adults) of West Bank and Gaza?
Your response must be concise. -3.2. In the year 2009, what is the difference between the ATMs(per 100,000 adults) in Montenegro and ATMs(per 100,000 adults) in Netherlands?
Your response must be concise. -2.35. In the year 2009, what is the difference between the ATMs(per 100,000 adults) in Montenegro and ATMs(per 100,000 adults) in West Bank and Gaza?
Offer a very short reply. 45.76. In the year 2009, what is the difference between the ATMs(per 100,000 adults) in Netherlands and ATMs(per 100,000 adults) in West Bank and Gaza?
Keep it short and to the point. 48.11. In the year 2010, what is the difference between the ATMs(per 100,000 adults) of Middle East & North Africa (developing only) and ATMs(per 100,000 adults) of Montenegro?
Offer a very short reply. -52.25. In the year 2010, what is the difference between the ATMs(per 100,000 adults) in Middle East & North Africa (developing only) and ATMs(per 100,000 adults) in Netherlands?
Give a very brief answer. -45.68. In the year 2010, what is the difference between the ATMs(per 100,000 adults) of Middle East & North Africa (developing only) and ATMs(per 100,000 adults) of West Bank and Gaza?
Give a very brief answer. -3.08. In the year 2010, what is the difference between the ATMs(per 100,000 adults) in Montenegro and ATMs(per 100,000 adults) in Netherlands?
Offer a terse response. 6.58. In the year 2010, what is the difference between the ATMs(per 100,000 adults) in Montenegro and ATMs(per 100,000 adults) in West Bank and Gaza?
Provide a succinct answer. 49.17. In the year 2010, what is the difference between the ATMs(per 100,000 adults) in Netherlands and ATMs(per 100,000 adults) in West Bank and Gaza?
Your answer should be compact. 42.6. In the year 2011, what is the difference between the ATMs(per 100,000 adults) in Middle East & North Africa (developing only) and ATMs(per 100,000 adults) in Montenegro?
Keep it short and to the point. -53.28. In the year 2011, what is the difference between the ATMs(per 100,000 adults) in Middle East & North Africa (developing only) and ATMs(per 100,000 adults) in Netherlands?
Make the answer very short. -43.49. In the year 2011, what is the difference between the ATMs(per 100,000 adults) in Middle East & North Africa (developing only) and ATMs(per 100,000 adults) in West Bank and Gaza?
Offer a very short reply. -3.38. In the year 2011, what is the difference between the ATMs(per 100,000 adults) of Montenegro and ATMs(per 100,000 adults) of Netherlands?
Your answer should be very brief. 9.79. In the year 2011, what is the difference between the ATMs(per 100,000 adults) in Montenegro and ATMs(per 100,000 adults) in West Bank and Gaza?
Ensure brevity in your answer.  49.9. In the year 2011, what is the difference between the ATMs(per 100,000 adults) of Netherlands and ATMs(per 100,000 adults) of West Bank and Gaza?
Your response must be concise. 40.11. In the year 2012, what is the difference between the ATMs(per 100,000 adults) of Middle East & North Africa (developing only) and ATMs(per 100,000 adults) of Montenegro?
Give a very brief answer. -55.17. In the year 2012, what is the difference between the ATMs(per 100,000 adults) in Middle East & North Africa (developing only) and ATMs(per 100,000 adults) in Netherlands?
Provide a short and direct response. -40.1. In the year 2012, what is the difference between the ATMs(per 100,000 adults) of Middle East & North Africa (developing only) and ATMs(per 100,000 adults) of West Bank and Gaza?
Make the answer very short. -3.66. In the year 2012, what is the difference between the ATMs(per 100,000 adults) in Montenegro and ATMs(per 100,000 adults) in Netherlands?
Your response must be concise. 15.07. In the year 2012, what is the difference between the ATMs(per 100,000 adults) of Montenegro and ATMs(per 100,000 adults) of West Bank and Gaza?
Provide a succinct answer. 51.51. In the year 2012, what is the difference between the ATMs(per 100,000 adults) of Netherlands and ATMs(per 100,000 adults) of West Bank and Gaza?
Provide a short and direct response. 36.44. In the year 2013, what is the difference between the ATMs(per 100,000 adults) of Middle East & North Africa (developing only) and ATMs(per 100,000 adults) of Montenegro?
Your response must be concise. -50.07. In the year 2013, what is the difference between the ATMs(per 100,000 adults) of Middle East & North Africa (developing only) and ATMs(per 100,000 adults) of Netherlands?
Ensure brevity in your answer.  -31.54. In the year 2013, what is the difference between the ATMs(per 100,000 adults) in Middle East & North Africa (developing only) and ATMs(per 100,000 adults) in West Bank and Gaza?
Offer a terse response. 1.9. In the year 2013, what is the difference between the ATMs(per 100,000 adults) in Montenegro and ATMs(per 100,000 adults) in Netherlands?
Offer a very short reply. 18.53. In the year 2013, what is the difference between the ATMs(per 100,000 adults) in Montenegro and ATMs(per 100,000 adults) in West Bank and Gaza?
Your answer should be compact. 51.98. In the year 2013, what is the difference between the ATMs(per 100,000 adults) in Netherlands and ATMs(per 100,000 adults) in West Bank and Gaza?
Provide a short and direct response. 33.45. What is the ratio of the ATMs(per 100,000 adults) of Middle East & North Africa (developing only) in 2006 to that in 2007?
Offer a very short reply. 0.6. What is the ratio of the ATMs(per 100,000 adults) of Montenegro in 2006 to that in 2007?
Offer a terse response. 0.65. What is the ratio of the ATMs(per 100,000 adults) in Netherlands in 2006 to that in 2007?
Offer a very short reply. 0.95. What is the ratio of the ATMs(per 100,000 adults) in West Bank and Gaza in 2006 to that in 2007?
Ensure brevity in your answer.  0.76. What is the ratio of the ATMs(per 100,000 adults) of Middle East & North Africa (developing only) in 2006 to that in 2008?
Provide a short and direct response. 0.68. What is the ratio of the ATMs(per 100,000 adults) of Montenegro in 2006 to that in 2008?
Your response must be concise. 0.49. What is the ratio of the ATMs(per 100,000 adults) in Netherlands in 2006 to that in 2008?
Your answer should be very brief. 0.95. What is the ratio of the ATMs(per 100,000 adults) in West Bank and Gaza in 2006 to that in 2008?
Make the answer very short. 0.68. What is the ratio of the ATMs(per 100,000 adults) in Middle East & North Africa (developing only) in 2006 to that in 2009?
Provide a short and direct response. 0.56. What is the ratio of the ATMs(per 100,000 adults) of Montenegro in 2006 to that in 2009?
Offer a very short reply. 0.43. What is the ratio of the ATMs(per 100,000 adults) in Netherlands in 2006 to that in 2009?
Your answer should be compact. 0.97. What is the ratio of the ATMs(per 100,000 adults) of West Bank and Gaza in 2006 to that in 2009?
Give a very brief answer. 0.56. What is the ratio of the ATMs(per 100,000 adults) in Middle East & North Africa (developing only) in 2006 to that in 2010?
Provide a succinct answer. 0.52. What is the ratio of the ATMs(per 100,000 adults) in Montenegro in 2006 to that in 2010?
Give a very brief answer. 0.4. What is the ratio of the ATMs(per 100,000 adults) of Netherlands in 2006 to that in 2010?
Ensure brevity in your answer.  1.05. What is the ratio of the ATMs(per 100,000 adults) in West Bank and Gaza in 2006 to that in 2010?
Provide a succinct answer. 0.53. What is the ratio of the ATMs(per 100,000 adults) in Middle East & North Africa (developing only) in 2006 to that in 2011?
Your answer should be very brief. 0.48. What is the ratio of the ATMs(per 100,000 adults) of Montenegro in 2006 to that in 2011?
Provide a succinct answer. 0.39. What is the ratio of the ATMs(per 100,000 adults) in Netherlands in 2006 to that in 2011?
Keep it short and to the point. 1.07. What is the ratio of the ATMs(per 100,000 adults) in West Bank and Gaza in 2006 to that in 2011?
Make the answer very short. 0.49. What is the ratio of the ATMs(per 100,000 adults) in Middle East & North Africa (developing only) in 2006 to that in 2012?
Provide a short and direct response. 0.44. What is the ratio of the ATMs(per 100,000 adults) of Montenegro in 2006 to that in 2012?
Your response must be concise. 0.37. What is the ratio of the ATMs(per 100,000 adults) of Netherlands in 2006 to that in 2012?
Offer a terse response. 1.11. What is the ratio of the ATMs(per 100,000 adults) in West Bank and Gaza in 2006 to that in 2012?
Provide a short and direct response. 0.44. What is the ratio of the ATMs(per 100,000 adults) of Middle East & North Africa (developing only) in 2006 to that in 2013?
Keep it short and to the point. 0.29. What is the ratio of the ATMs(per 100,000 adults) of Montenegro in 2006 to that in 2013?
Offer a very short reply. 0.36. What is the ratio of the ATMs(per 100,000 adults) of Netherlands in 2006 to that in 2013?
Offer a terse response. 1.15. What is the ratio of the ATMs(per 100,000 adults) of West Bank and Gaza in 2006 to that in 2013?
Offer a very short reply. 0.41. What is the ratio of the ATMs(per 100,000 adults) in Middle East & North Africa (developing only) in 2007 to that in 2008?
Your response must be concise. 1.14. What is the ratio of the ATMs(per 100,000 adults) of Montenegro in 2007 to that in 2008?
Your answer should be very brief. 0.76. What is the ratio of the ATMs(per 100,000 adults) in West Bank and Gaza in 2007 to that in 2008?
Offer a very short reply. 0.89. What is the ratio of the ATMs(per 100,000 adults) in Middle East & North Africa (developing only) in 2007 to that in 2009?
Provide a succinct answer. 0.94. What is the ratio of the ATMs(per 100,000 adults) in Montenegro in 2007 to that in 2009?
Offer a very short reply. 0.67. What is the ratio of the ATMs(per 100,000 adults) of Netherlands in 2007 to that in 2009?
Offer a very short reply. 1.02. What is the ratio of the ATMs(per 100,000 adults) in West Bank and Gaza in 2007 to that in 2009?
Your answer should be compact. 0.73. What is the ratio of the ATMs(per 100,000 adults) in Middle East & North Africa (developing only) in 2007 to that in 2010?
Provide a short and direct response. 0.87. What is the ratio of the ATMs(per 100,000 adults) in Montenegro in 2007 to that in 2010?
Keep it short and to the point. 0.62. What is the ratio of the ATMs(per 100,000 adults) of Netherlands in 2007 to that in 2010?
Your answer should be very brief. 1.1. What is the ratio of the ATMs(per 100,000 adults) of West Bank and Gaza in 2007 to that in 2010?
Your response must be concise. 0.7. What is the ratio of the ATMs(per 100,000 adults) of Middle East & North Africa (developing only) in 2007 to that in 2011?
Make the answer very short. 0.81. What is the ratio of the ATMs(per 100,000 adults) in Montenegro in 2007 to that in 2011?
Provide a short and direct response. 0.6. What is the ratio of the ATMs(per 100,000 adults) in Netherlands in 2007 to that in 2011?
Your answer should be very brief. 1.13. What is the ratio of the ATMs(per 100,000 adults) of West Bank and Gaza in 2007 to that in 2011?
Your response must be concise. 0.64. What is the ratio of the ATMs(per 100,000 adults) in Middle East & North Africa (developing only) in 2007 to that in 2012?
Provide a short and direct response. 0.73. What is the ratio of the ATMs(per 100,000 adults) in Montenegro in 2007 to that in 2012?
Provide a succinct answer. 0.58. What is the ratio of the ATMs(per 100,000 adults) of Netherlands in 2007 to that in 2012?
Give a very brief answer. 1.17. What is the ratio of the ATMs(per 100,000 adults) of West Bank and Gaza in 2007 to that in 2012?
Your answer should be very brief. 0.58. What is the ratio of the ATMs(per 100,000 adults) in Middle East & North Africa (developing only) in 2007 to that in 2013?
Make the answer very short. 0.49. What is the ratio of the ATMs(per 100,000 adults) of Montenegro in 2007 to that in 2013?
Keep it short and to the point. 0.56. What is the ratio of the ATMs(per 100,000 adults) in Netherlands in 2007 to that in 2013?
Provide a succinct answer. 1.2. What is the ratio of the ATMs(per 100,000 adults) in West Bank and Gaza in 2007 to that in 2013?
Make the answer very short. 0.54. What is the ratio of the ATMs(per 100,000 adults) in Middle East & North Africa (developing only) in 2008 to that in 2009?
Provide a short and direct response. 0.83. What is the ratio of the ATMs(per 100,000 adults) in Montenegro in 2008 to that in 2009?
Ensure brevity in your answer.  0.88. What is the ratio of the ATMs(per 100,000 adults) of Netherlands in 2008 to that in 2009?
Your response must be concise. 1.03. What is the ratio of the ATMs(per 100,000 adults) of West Bank and Gaza in 2008 to that in 2009?
Offer a terse response. 0.82. What is the ratio of the ATMs(per 100,000 adults) in Middle East & North Africa (developing only) in 2008 to that in 2010?
Your response must be concise. 0.77. What is the ratio of the ATMs(per 100,000 adults) of Montenegro in 2008 to that in 2010?
Offer a very short reply. 0.83. What is the ratio of the ATMs(per 100,000 adults) in Netherlands in 2008 to that in 2010?
Provide a short and direct response. 1.11. What is the ratio of the ATMs(per 100,000 adults) in West Bank and Gaza in 2008 to that in 2010?
Your answer should be compact. 0.78. What is the ratio of the ATMs(per 100,000 adults) in Middle East & North Africa (developing only) in 2008 to that in 2011?
Make the answer very short. 0.71. What is the ratio of the ATMs(per 100,000 adults) in Montenegro in 2008 to that in 2011?
Give a very brief answer. 0.8. What is the ratio of the ATMs(per 100,000 adults) of Netherlands in 2008 to that in 2011?
Offer a very short reply. 1.13. What is the ratio of the ATMs(per 100,000 adults) of West Bank and Gaza in 2008 to that in 2011?
Provide a succinct answer. 0.72. What is the ratio of the ATMs(per 100,000 adults) in Middle East & North Africa (developing only) in 2008 to that in 2012?
Make the answer very short. 0.64. What is the ratio of the ATMs(per 100,000 adults) of Montenegro in 2008 to that in 2012?
Offer a very short reply. 0.76. What is the ratio of the ATMs(per 100,000 adults) in Netherlands in 2008 to that in 2012?
Give a very brief answer. 1.17. What is the ratio of the ATMs(per 100,000 adults) in West Bank and Gaza in 2008 to that in 2012?
Ensure brevity in your answer.  0.65. What is the ratio of the ATMs(per 100,000 adults) in Middle East & North Africa (developing only) in 2008 to that in 2013?
Make the answer very short. 0.43. What is the ratio of the ATMs(per 100,000 adults) in Montenegro in 2008 to that in 2013?
Ensure brevity in your answer.  0.74. What is the ratio of the ATMs(per 100,000 adults) of Netherlands in 2008 to that in 2013?
Your response must be concise. 1.21. What is the ratio of the ATMs(per 100,000 adults) in West Bank and Gaza in 2008 to that in 2013?
Your answer should be very brief. 0.61. What is the ratio of the ATMs(per 100,000 adults) of Middle East & North Africa (developing only) in 2009 to that in 2010?
Give a very brief answer. 0.93. What is the ratio of the ATMs(per 100,000 adults) of Montenegro in 2009 to that in 2010?
Your answer should be compact. 0.94. What is the ratio of the ATMs(per 100,000 adults) of Netherlands in 2009 to that in 2010?
Make the answer very short. 1.08. What is the ratio of the ATMs(per 100,000 adults) of West Bank and Gaza in 2009 to that in 2010?
Provide a succinct answer. 0.95. What is the ratio of the ATMs(per 100,000 adults) of Middle East & North Africa (developing only) in 2009 to that in 2011?
Provide a succinct answer. 0.86. What is the ratio of the ATMs(per 100,000 adults) of Montenegro in 2009 to that in 2011?
Offer a terse response. 0.91. What is the ratio of the ATMs(per 100,000 adults) of Netherlands in 2009 to that in 2011?
Provide a succinct answer. 1.11. What is the ratio of the ATMs(per 100,000 adults) of West Bank and Gaza in 2009 to that in 2011?
Make the answer very short. 0.88. What is the ratio of the ATMs(per 100,000 adults) in Middle East & North Africa (developing only) in 2009 to that in 2012?
Provide a short and direct response. 0.77. What is the ratio of the ATMs(per 100,000 adults) of Montenegro in 2009 to that in 2012?
Make the answer very short. 0.86. What is the ratio of the ATMs(per 100,000 adults) in Netherlands in 2009 to that in 2012?
Your answer should be compact. 1.15. What is the ratio of the ATMs(per 100,000 adults) of West Bank and Gaza in 2009 to that in 2012?
Give a very brief answer. 0.79. What is the ratio of the ATMs(per 100,000 adults) in Middle East & North Africa (developing only) in 2009 to that in 2013?
Ensure brevity in your answer.  0.52. What is the ratio of the ATMs(per 100,000 adults) in Montenegro in 2009 to that in 2013?
Ensure brevity in your answer.  0.84. What is the ratio of the ATMs(per 100,000 adults) in Netherlands in 2009 to that in 2013?
Make the answer very short. 1.18. What is the ratio of the ATMs(per 100,000 adults) in West Bank and Gaza in 2009 to that in 2013?
Make the answer very short. 0.74. What is the ratio of the ATMs(per 100,000 adults) of Middle East & North Africa (developing only) in 2010 to that in 2011?
Give a very brief answer. 0.93. What is the ratio of the ATMs(per 100,000 adults) in Montenegro in 2010 to that in 2011?
Offer a very short reply. 0.97. What is the ratio of the ATMs(per 100,000 adults) of Netherlands in 2010 to that in 2011?
Your response must be concise. 1.02. What is the ratio of the ATMs(per 100,000 adults) of West Bank and Gaza in 2010 to that in 2011?
Make the answer very short. 0.92. What is the ratio of the ATMs(per 100,000 adults) in Middle East & North Africa (developing only) in 2010 to that in 2012?
Keep it short and to the point. 0.84. What is the ratio of the ATMs(per 100,000 adults) in Montenegro in 2010 to that in 2012?
Your answer should be very brief. 0.92. What is the ratio of the ATMs(per 100,000 adults) of Netherlands in 2010 to that in 2012?
Your answer should be very brief. 1.06. What is the ratio of the ATMs(per 100,000 adults) in West Bank and Gaza in 2010 to that in 2012?
Provide a short and direct response. 0.84. What is the ratio of the ATMs(per 100,000 adults) of Middle East & North Africa (developing only) in 2010 to that in 2013?
Keep it short and to the point. 0.56. What is the ratio of the ATMs(per 100,000 adults) of Montenegro in 2010 to that in 2013?
Provide a succinct answer. 0.9. What is the ratio of the ATMs(per 100,000 adults) in Netherlands in 2010 to that in 2013?
Offer a very short reply. 1.09. What is the ratio of the ATMs(per 100,000 adults) in West Bank and Gaza in 2010 to that in 2013?
Ensure brevity in your answer.  0.78. What is the ratio of the ATMs(per 100,000 adults) of Middle East & North Africa (developing only) in 2011 to that in 2012?
Keep it short and to the point. 0.9. What is the ratio of the ATMs(per 100,000 adults) of Montenegro in 2011 to that in 2012?
Ensure brevity in your answer.  0.95. What is the ratio of the ATMs(per 100,000 adults) of Netherlands in 2011 to that in 2012?
Make the answer very short. 1.04. What is the ratio of the ATMs(per 100,000 adults) in West Bank and Gaza in 2011 to that in 2012?
Your response must be concise. 0.91. What is the ratio of the ATMs(per 100,000 adults) in Middle East & North Africa (developing only) in 2011 to that in 2013?
Your answer should be very brief. 0.61. What is the ratio of the ATMs(per 100,000 adults) in Montenegro in 2011 to that in 2013?
Offer a terse response. 0.93. What is the ratio of the ATMs(per 100,000 adults) of Netherlands in 2011 to that in 2013?
Offer a terse response. 1.07. What is the ratio of the ATMs(per 100,000 adults) in West Bank and Gaza in 2011 to that in 2013?
Give a very brief answer. 0.84. What is the ratio of the ATMs(per 100,000 adults) in Middle East & North Africa (developing only) in 2012 to that in 2013?
Keep it short and to the point. 0.67. What is the ratio of the ATMs(per 100,000 adults) in Montenegro in 2012 to that in 2013?
Ensure brevity in your answer.  0.97. What is the ratio of the ATMs(per 100,000 adults) in Netherlands in 2012 to that in 2013?
Your answer should be compact. 1.03. What is the ratio of the ATMs(per 100,000 adults) of West Bank and Gaza in 2012 to that in 2013?
Your response must be concise. 0.93. What is the difference between the highest and the second highest ATMs(per 100,000 adults) in Middle East & North Africa (developing only)?
Offer a terse response. 6.98. What is the difference between the highest and the second highest ATMs(per 100,000 adults) in Montenegro?
Provide a succinct answer. 1.88. What is the difference between the highest and the second highest ATMs(per 100,000 adults) of Netherlands?
Keep it short and to the point. 0.39. What is the difference between the highest and the second highest ATMs(per 100,000 adults) in West Bank and Gaza?
Give a very brief answer. 1.41. What is the difference between the highest and the lowest ATMs(per 100,000 adults) in Middle East & North Africa (developing only)?
Your answer should be very brief. 15.13. What is the difference between the highest and the lowest ATMs(per 100,000 adults) of Montenegro?
Keep it short and to the point. 45.51. What is the difference between the highest and the lowest ATMs(per 100,000 adults) in Netherlands?
Provide a succinct answer. 11.11. What is the difference between the highest and the lowest ATMs(per 100,000 adults) of West Bank and Gaza?
Your answer should be compact. 11.51. 